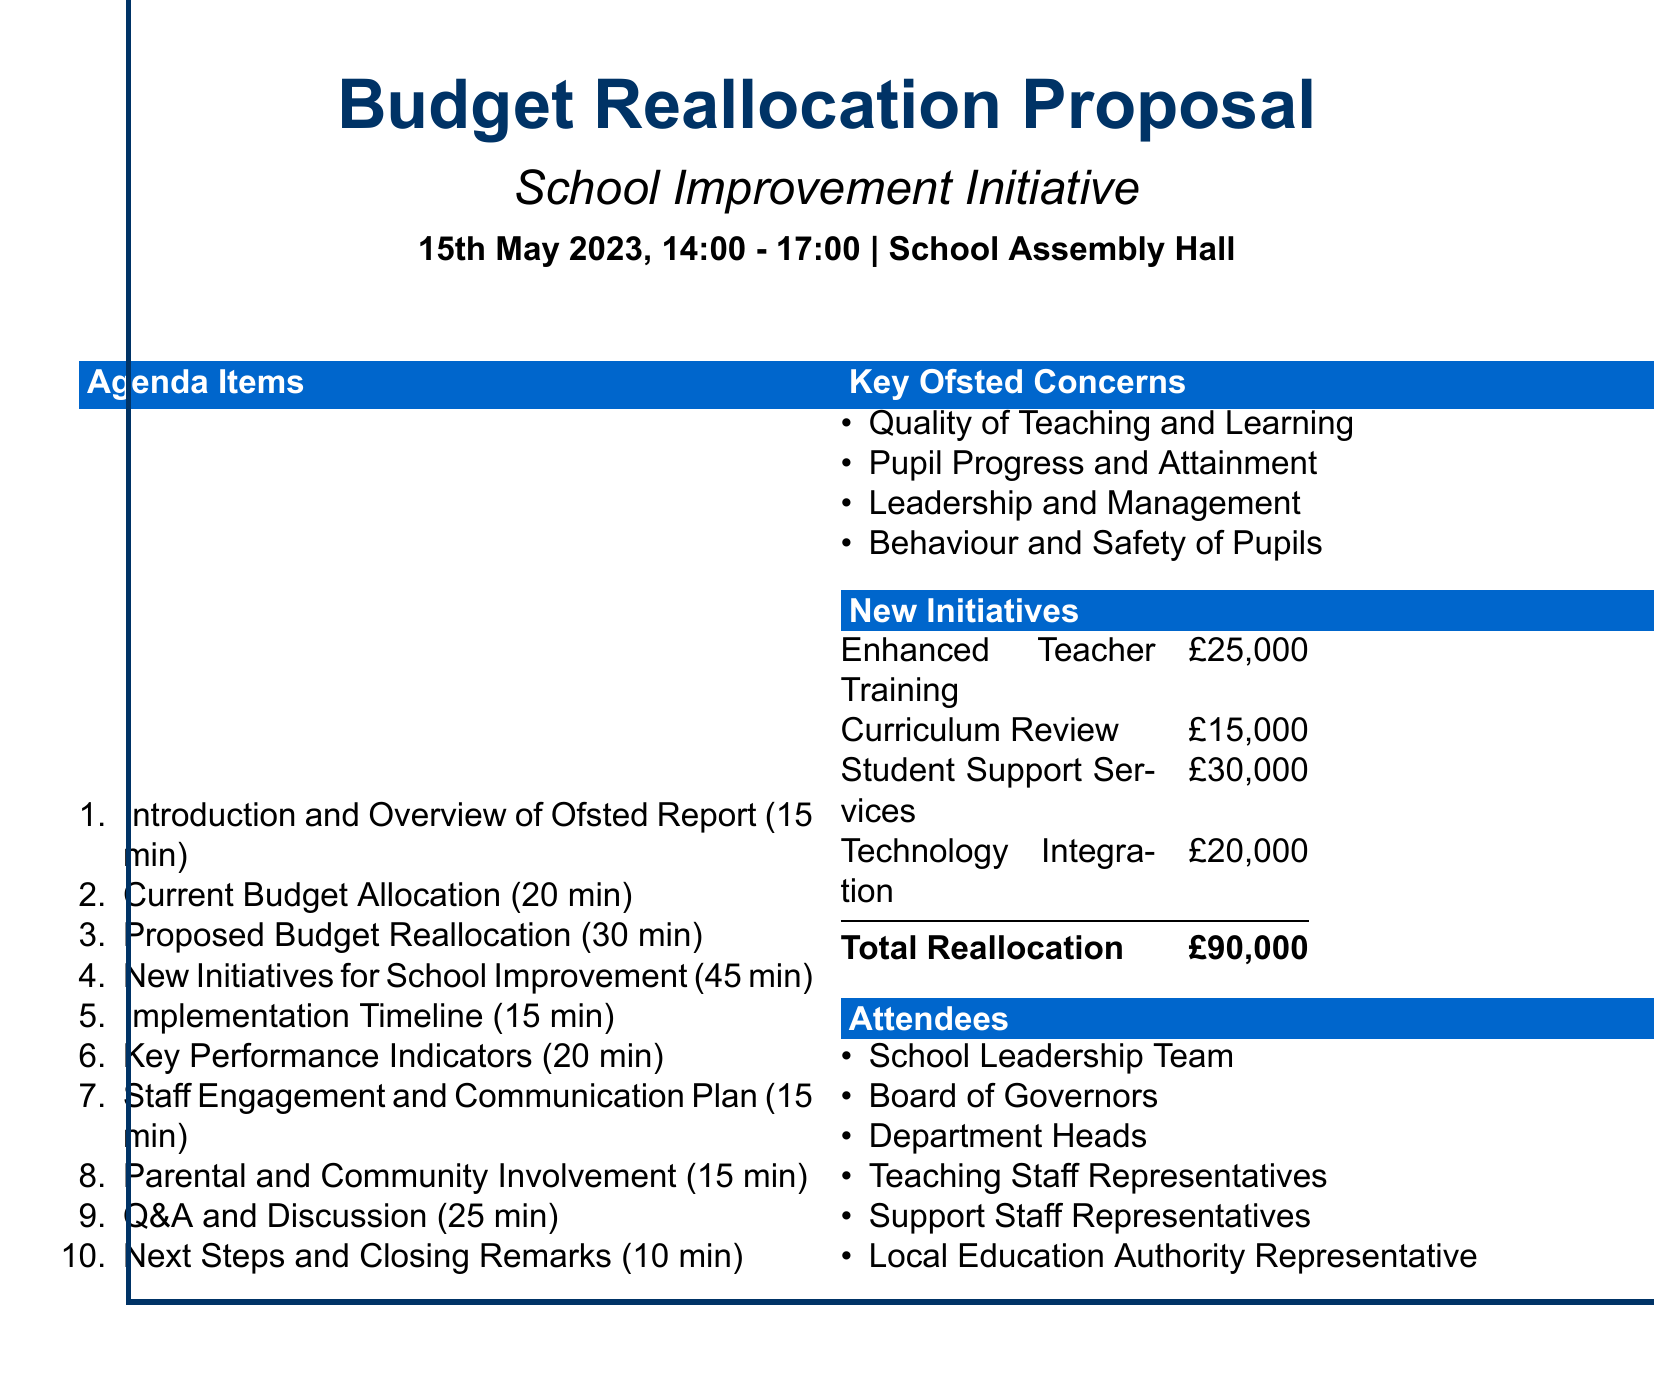What is the total budget reallocation? The total budget reallocation is stated at the bottom of the document as the sum of the proposed allocations.
Answer: £90,000 Who presents the proposed budget reallocation? The presenter for the proposed budget reallocation is indicated in that agenda item.
Answer: Headteacher and School Business Manager How long is the Q&A and Discussion session? The duration of the Q&A and Discussion session is specified in the agenda.
Answer: 25 minutes What is one of the key concerns from the Ofsted report? One of the key Ofsted concerns is listed in the document as a focus area for improvement.
Answer: Quality of Teaching and Learning Which new initiative requires the highest budget allocation? The document lists budget allocations for new initiatives, allowing for comparison to find the highest.
Answer: Student Support Services Expansion What is the venue for the meeting? The venue is clearly stated at the beginning of the document.
Answer: School Assembly Hall How much is allocated to Technology Integration? The budget allocation for Technology Integration is itemized in the new initiatives section.
Answer: £20,000 Who is responsible for presenting the Implementation Timeline? This information is found in the agenda, listing presenters for each item.
Answer: Deputy Headteacher 